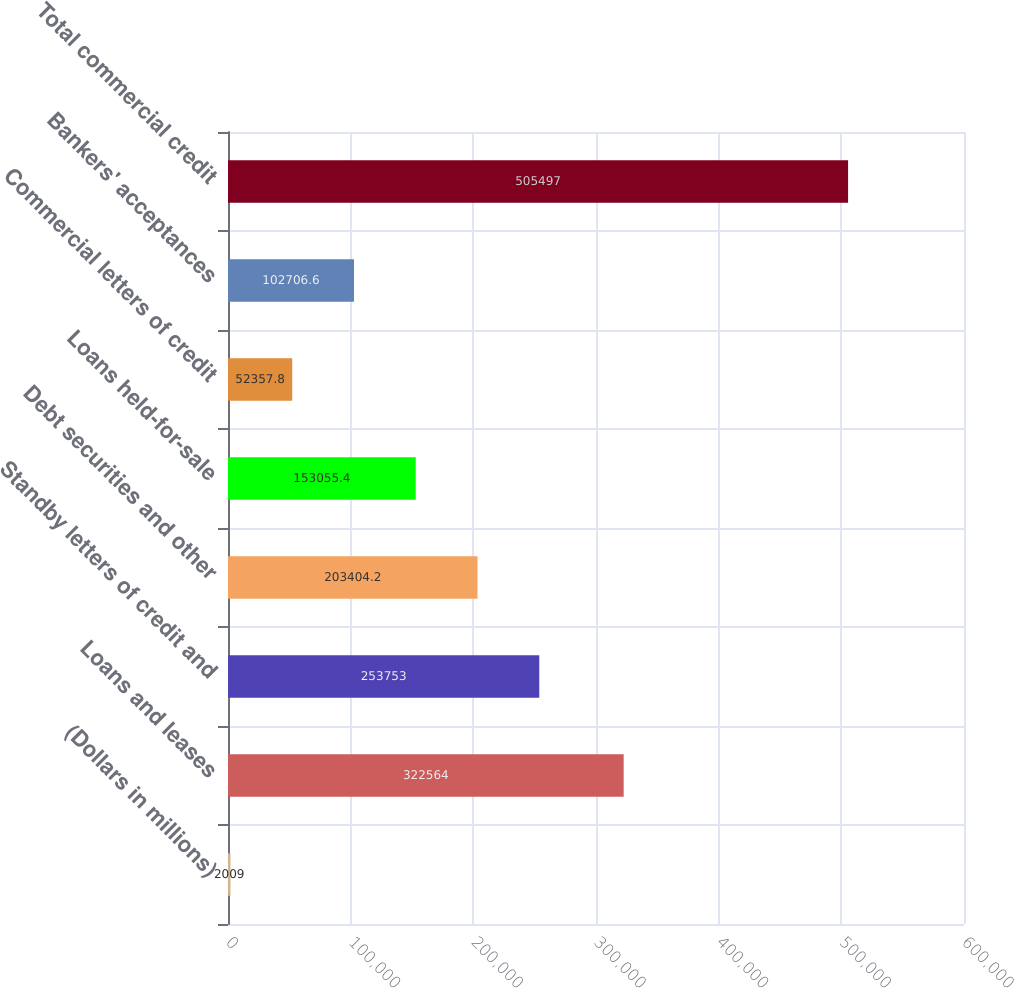<chart> <loc_0><loc_0><loc_500><loc_500><bar_chart><fcel>(Dollars in millions)<fcel>Loans and leases<fcel>Standby letters of credit and<fcel>Debt securities and other<fcel>Loans held-for-sale<fcel>Commercial letters of credit<fcel>Bankers' acceptances<fcel>Total commercial credit<nl><fcel>2009<fcel>322564<fcel>253753<fcel>203404<fcel>153055<fcel>52357.8<fcel>102707<fcel>505497<nl></chart> 